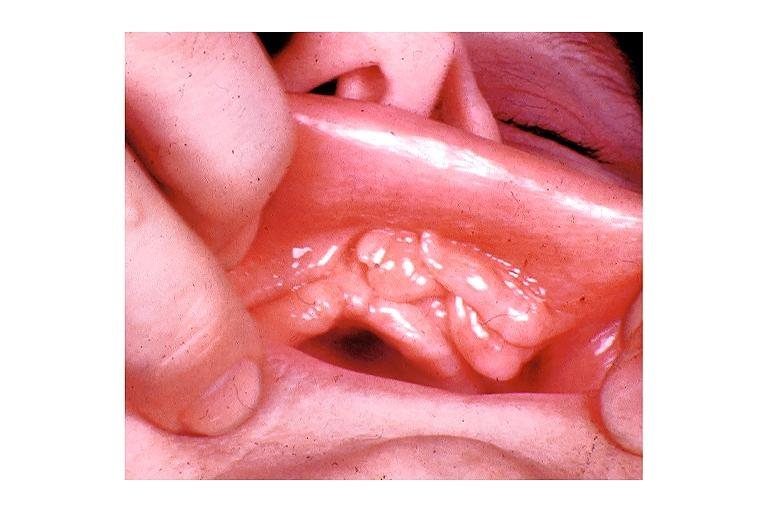does notochord show epulis fissuratum?
Answer the question using a single word or phrase. No 